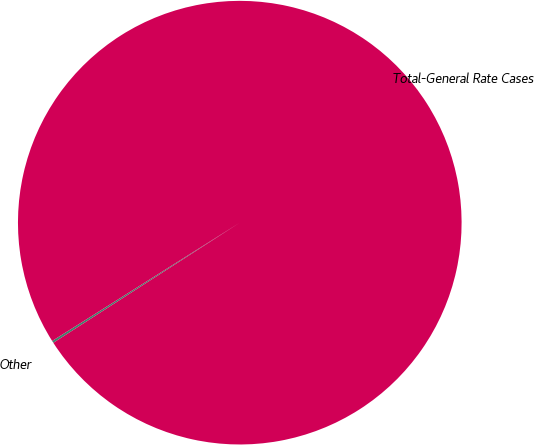Convert chart. <chart><loc_0><loc_0><loc_500><loc_500><pie_chart><fcel>Other<fcel>Total-General Rate Cases<nl><fcel>0.16%<fcel>99.84%<nl></chart> 